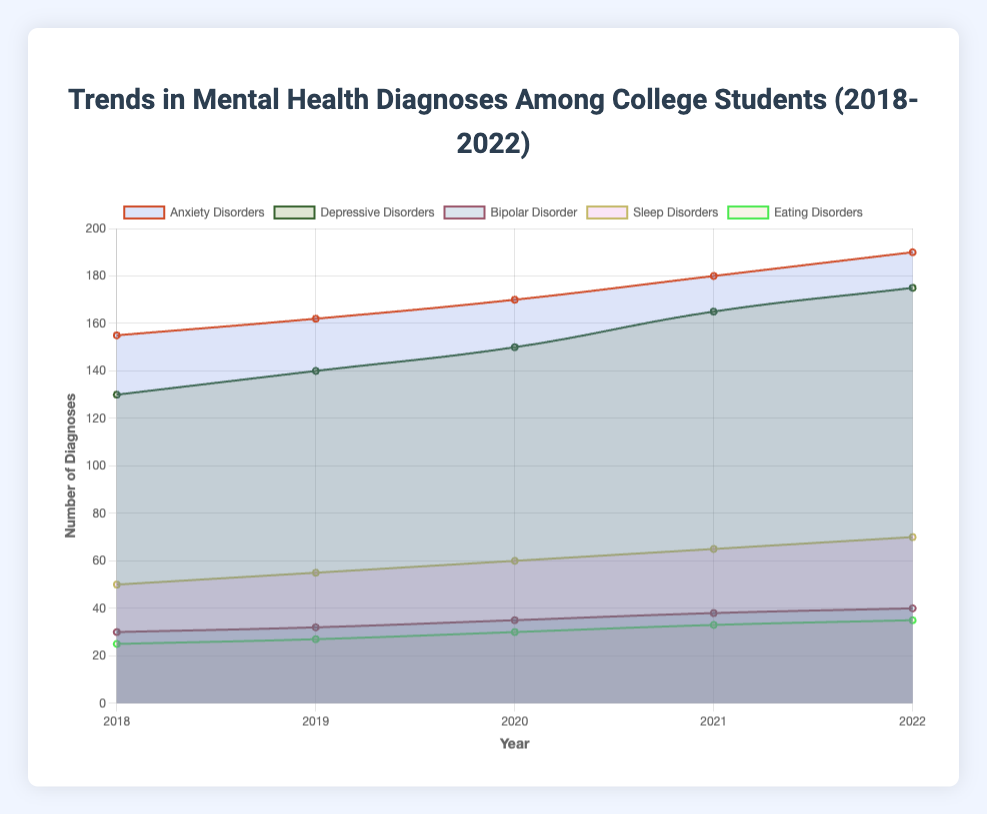What is the title of the chart? The title of the chart is typically located at the top and it provides a summary of what the data represents. In this case, the title is "Trends in Mental Health Diagnoses Among College Students (2018-2022)" as seen at the top of the chart.
Answer: Trends in Mental Health Diagnoses Among College Students (2018-2022) What is the trend of Anxiety Disorders diagnoses from 2018 to 2022? To determine the trend, observe the plot for Anxiety Disorders over the years. The counts increased from 155 in 2018 to 190 in 2022, showing a consistent upward trend.
Answer: Upward trend Which mental health diagnosis had the lowest number of cases in 2018? Look for the lowest data point in the year 2018. Among Anxiety Disorders (155), Depressive Disorders (130), Bipolar Disorder (30), Sleep Disorders (50), and Eating Disorders (25), Eating Disorders had the lowest count.
Answer: Eating Disorders How did the number of Depressive Disorders diagnoses change over the years? To answer this, look across the years for Depressive Disorders. The counts are 130, 140, 150, 165, and 175 from 2018 to 2022, showing a continuous increase each year.
Answer: Increased each year Which disorder showed the least variation in the number of diagnoses over the period? To identify this, examine the changes in the counts for all diagnoses. Bipolar Disorder's counts varied from 30 to 40, showing the smallest range of changes compared to others.
Answer: Bipolar Disorder What is the average number of Sleep Disorders diagnoses from 2018 to 2022? Calculate the mean by summing the counts for Sleep Disorders over the years (50 + 55 + 60 + 65 + 70) = 300, then divide by the number of years, i.e., 300 / 5 = 60.
Answer: 60 Which disorder had the highest count in 2022? Identify the highest count among the disorders in the year 2022. Anxiety Disorders had counts of 190, which is the highest compared to other disorders.
Answer: Anxiety Disorders Compare the increase in cases of Eating Disorders to Bipolar Disorder from 2018 to 2022. Which increased more? Calculate the difference from 2022 to 2018 for both disorders. Eating Disorders increased by 35 - 25 = 10 and Bipolar Disorder by 40 - 30 = 10. Both increased by the same amount.
Answer: Both increased by 10 What is the total number of diagnoses for all disorders in 2020? Sum the counts for all disorders in 2020. They are Anxiety Disorders (170), Depressive Disorders (150), Bipolar Disorder (35), Sleep Disorders (60), and Eating Disorders (30). The total is 170 + 150 + 35 + 60 + 30 = 445.
Answer: 445 